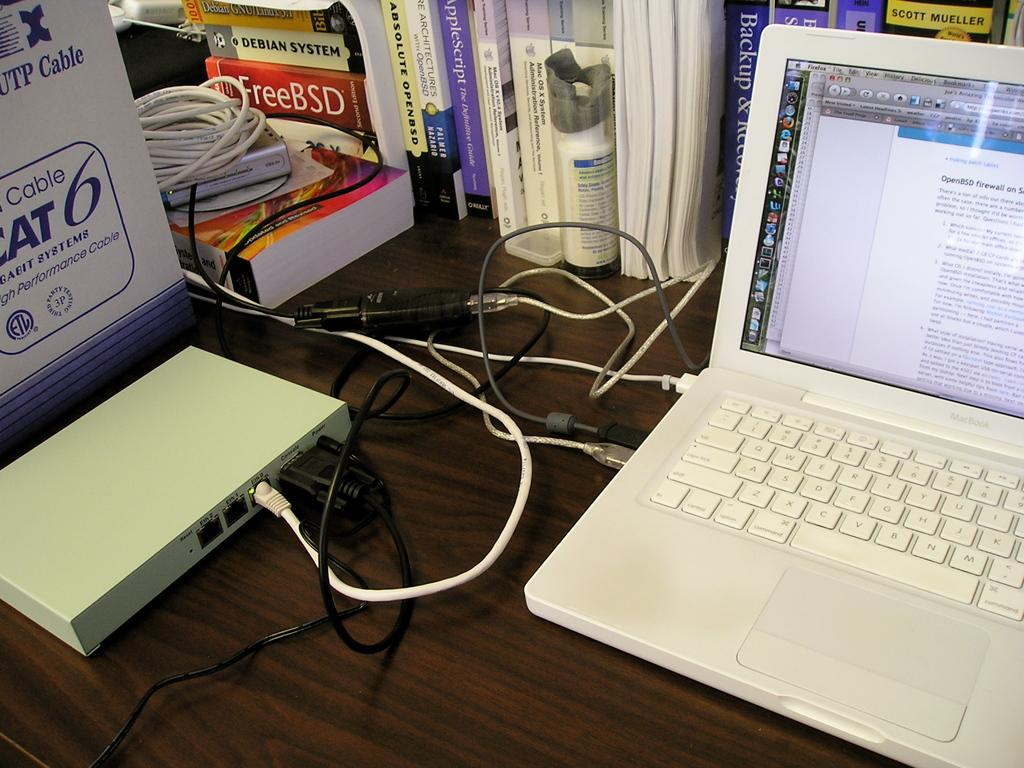<image>
Render a clear and concise summary of the photo. A Mac laptop has a screen open with information about OpenBSD firewalls. 